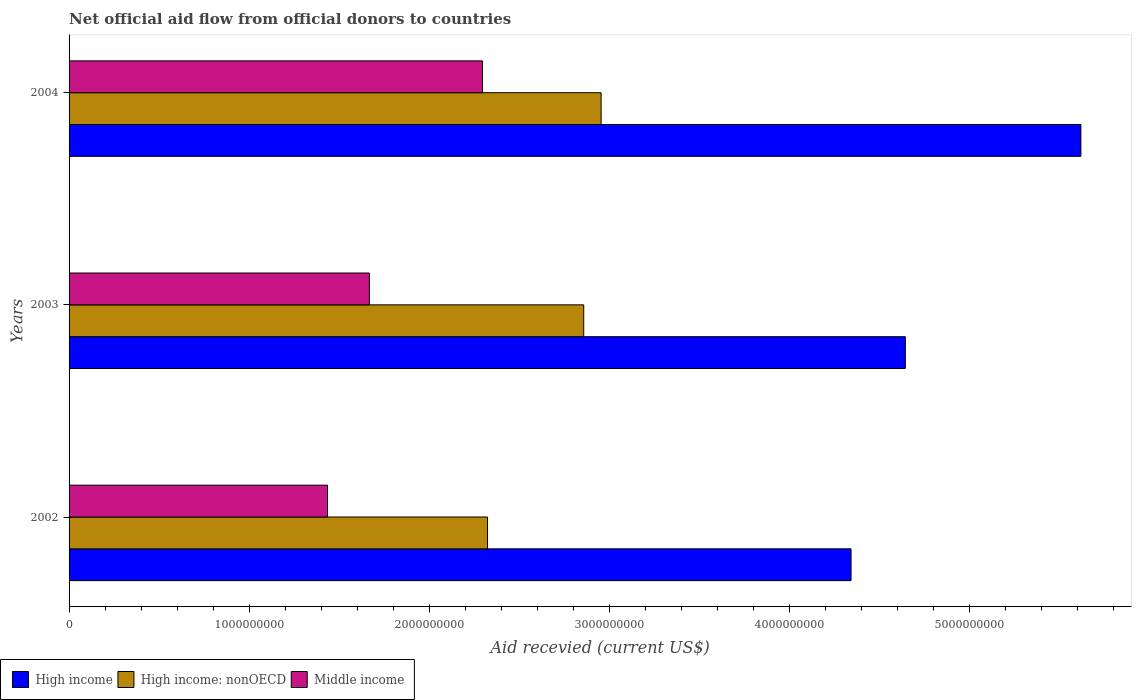How many groups of bars are there?
Offer a terse response. 3. Are the number of bars on each tick of the Y-axis equal?
Ensure brevity in your answer.  Yes. What is the label of the 1st group of bars from the top?
Your answer should be very brief. 2004. What is the total aid received in Middle income in 2002?
Make the answer very short. 1.43e+09. Across all years, what is the maximum total aid received in High income?
Offer a terse response. 5.62e+09. Across all years, what is the minimum total aid received in Middle income?
Your response must be concise. 1.43e+09. In which year was the total aid received in Middle income maximum?
Your response must be concise. 2004. What is the total total aid received in High income in the graph?
Your response must be concise. 1.46e+1. What is the difference between the total aid received in Middle income in 2002 and that in 2004?
Your answer should be very brief. -8.61e+08. What is the difference between the total aid received in High income: nonOECD in 2004 and the total aid received in High income in 2002?
Provide a succinct answer. -1.39e+09. What is the average total aid received in High income: nonOECD per year?
Keep it short and to the point. 2.71e+09. In the year 2004, what is the difference between the total aid received in High income and total aid received in High income: nonOECD?
Make the answer very short. 2.66e+09. In how many years, is the total aid received in Middle income greater than 800000000 US$?
Your answer should be compact. 3. What is the ratio of the total aid received in High income: nonOECD in 2003 to that in 2004?
Your answer should be very brief. 0.97. Is the total aid received in High income: nonOECD in 2002 less than that in 2003?
Your answer should be compact. Yes. Is the difference between the total aid received in High income in 2003 and 2004 greater than the difference between the total aid received in High income: nonOECD in 2003 and 2004?
Keep it short and to the point. No. What is the difference between the highest and the second highest total aid received in Middle income?
Provide a succinct answer. 6.28e+08. What is the difference between the highest and the lowest total aid received in High income?
Make the answer very short. 1.28e+09. In how many years, is the total aid received in Middle income greater than the average total aid received in Middle income taken over all years?
Provide a short and direct response. 1. What does the 2nd bar from the top in 2003 represents?
Provide a succinct answer. High income: nonOECD. What does the 1st bar from the bottom in 2004 represents?
Your answer should be compact. High income. Are the values on the major ticks of X-axis written in scientific E-notation?
Give a very brief answer. No. Where does the legend appear in the graph?
Your response must be concise. Bottom left. What is the title of the graph?
Provide a succinct answer. Net official aid flow from official donors to countries. Does "Sub-Saharan Africa (developing only)" appear as one of the legend labels in the graph?
Give a very brief answer. No. What is the label or title of the X-axis?
Make the answer very short. Aid recevied (current US$). What is the label or title of the Y-axis?
Provide a succinct answer. Years. What is the Aid recevied (current US$) of High income in 2002?
Keep it short and to the point. 4.34e+09. What is the Aid recevied (current US$) of High income: nonOECD in 2002?
Ensure brevity in your answer.  2.32e+09. What is the Aid recevied (current US$) in Middle income in 2002?
Your answer should be very brief. 1.43e+09. What is the Aid recevied (current US$) of High income in 2003?
Ensure brevity in your answer.  4.64e+09. What is the Aid recevied (current US$) of High income: nonOECD in 2003?
Make the answer very short. 2.86e+09. What is the Aid recevied (current US$) in Middle income in 2003?
Your answer should be very brief. 1.67e+09. What is the Aid recevied (current US$) of High income in 2004?
Offer a terse response. 5.62e+09. What is the Aid recevied (current US$) in High income: nonOECD in 2004?
Provide a succinct answer. 2.95e+09. What is the Aid recevied (current US$) of Middle income in 2004?
Give a very brief answer. 2.30e+09. Across all years, what is the maximum Aid recevied (current US$) in High income?
Your answer should be compact. 5.62e+09. Across all years, what is the maximum Aid recevied (current US$) of High income: nonOECD?
Your response must be concise. 2.95e+09. Across all years, what is the maximum Aid recevied (current US$) in Middle income?
Give a very brief answer. 2.30e+09. Across all years, what is the minimum Aid recevied (current US$) of High income?
Your answer should be compact. 4.34e+09. Across all years, what is the minimum Aid recevied (current US$) of High income: nonOECD?
Your answer should be compact. 2.32e+09. Across all years, what is the minimum Aid recevied (current US$) in Middle income?
Your answer should be compact. 1.43e+09. What is the total Aid recevied (current US$) of High income in the graph?
Offer a terse response. 1.46e+1. What is the total Aid recevied (current US$) of High income: nonOECD in the graph?
Make the answer very short. 8.13e+09. What is the total Aid recevied (current US$) of Middle income in the graph?
Your response must be concise. 5.40e+09. What is the difference between the Aid recevied (current US$) in High income in 2002 and that in 2003?
Your answer should be compact. -3.01e+08. What is the difference between the Aid recevied (current US$) of High income: nonOECD in 2002 and that in 2003?
Keep it short and to the point. -5.34e+08. What is the difference between the Aid recevied (current US$) of Middle income in 2002 and that in 2003?
Your answer should be very brief. -2.33e+08. What is the difference between the Aid recevied (current US$) in High income in 2002 and that in 2004?
Ensure brevity in your answer.  -1.28e+09. What is the difference between the Aid recevied (current US$) in High income: nonOECD in 2002 and that in 2004?
Give a very brief answer. -6.31e+08. What is the difference between the Aid recevied (current US$) of Middle income in 2002 and that in 2004?
Offer a terse response. -8.61e+08. What is the difference between the Aid recevied (current US$) in High income in 2003 and that in 2004?
Provide a succinct answer. -9.75e+08. What is the difference between the Aid recevied (current US$) of High income: nonOECD in 2003 and that in 2004?
Offer a terse response. -9.65e+07. What is the difference between the Aid recevied (current US$) in Middle income in 2003 and that in 2004?
Offer a very short reply. -6.28e+08. What is the difference between the Aid recevied (current US$) in High income in 2002 and the Aid recevied (current US$) in High income: nonOECD in 2003?
Provide a succinct answer. 1.48e+09. What is the difference between the Aid recevied (current US$) in High income in 2002 and the Aid recevied (current US$) in Middle income in 2003?
Offer a very short reply. 2.67e+09. What is the difference between the Aid recevied (current US$) in High income: nonOECD in 2002 and the Aid recevied (current US$) in Middle income in 2003?
Provide a succinct answer. 6.56e+08. What is the difference between the Aid recevied (current US$) of High income in 2002 and the Aid recevied (current US$) of High income: nonOECD in 2004?
Give a very brief answer. 1.39e+09. What is the difference between the Aid recevied (current US$) of High income in 2002 and the Aid recevied (current US$) of Middle income in 2004?
Your answer should be very brief. 2.05e+09. What is the difference between the Aid recevied (current US$) of High income: nonOECD in 2002 and the Aid recevied (current US$) of Middle income in 2004?
Offer a very short reply. 2.79e+07. What is the difference between the Aid recevied (current US$) of High income in 2003 and the Aid recevied (current US$) of High income: nonOECD in 2004?
Your answer should be very brief. 1.69e+09. What is the difference between the Aid recevied (current US$) in High income in 2003 and the Aid recevied (current US$) in Middle income in 2004?
Your answer should be very brief. 2.35e+09. What is the difference between the Aid recevied (current US$) in High income: nonOECD in 2003 and the Aid recevied (current US$) in Middle income in 2004?
Provide a short and direct response. 5.62e+08. What is the average Aid recevied (current US$) of High income per year?
Make the answer very short. 4.87e+09. What is the average Aid recevied (current US$) in High income: nonOECD per year?
Keep it short and to the point. 2.71e+09. What is the average Aid recevied (current US$) of Middle income per year?
Your answer should be very brief. 1.80e+09. In the year 2002, what is the difference between the Aid recevied (current US$) of High income and Aid recevied (current US$) of High income: nonOECD?
Your answer should be compact. 2.02e+09. In the year 2002, what is the difference between the Aid recevied (current US$) in High income and Aid recevied (current US$) in Middle income?
Keep it short and to the point. 2.91e+09. In the year 2002, what is the difference between the Aid recevied (current US$) of High income: nonOECD and Aid recevied (current US$) of Middle income?
Offer a very short reply. 8.89e+08. In the year 2003, what is the difference between the Aid recevied (current US$) in High income and Aid recevied (current US$) in High income: nonOECD?
Your answer should be compact. 1.79e+09. In the year 2003, what is the difference between the Aid recevied (current US$) of High income and Aid recevied (current US$) of Middle income?
Your answer should be compact. 2.98e+09. In the year 2003, what is the difference between the Aid recevied (current US$) of High income: nonOECD and Aid recevied (current US$) of Middle income?
Offer a terse response. 1.19e+09. In the year 2004, what is the difference between the Aid recevied (current US$) in High income and Aid recevied (current US$) in High income: nonOECD?
Provide a succinct answer. 2.66e+09. In the year 2004, what is the difference between the Aid recevied (current US$) of High income and Aid recevied (current US$) of Middle income?
Your response must be concise. 3.32e+09. In the year 2004, what is the difference between the Aid recevied (current US$) in High income: nonOECD and Aid recevied (current US$) in Middle income?
Make the answer very short. 6.58e+08. What is the ratio of the Aid recevied (current US$) of High income in 2002 to that in 2003?
Provide a short and direct response. 0.94. What is the ratio of the Aid recevied (current US$) of High income: nonOECD in 2002 to that in 2003?
Provide a succinct answer. 0.81. What is the ratio of the Aid recevied (current US$) of Middle income in 2002 to that in 2003?
Offer a terse response. 0.86. What is the ratio of the Aid recevied (current US$) of High income in 2002 to that in 2004?
Keep it short and to the point. 0.77. What is the ratio of the Aid recevied (current US$) in High income: nonOECD in 2002 to that in 2004?
Your answer should be very brief. 0.79. What is the ratio of the Aid recevied (current US$) of Middle income in 2002 to that in 2004?
Ensure brevity in your answer.  0.62. What is the ratio of the Aid recevied (current US$) in High income in 2003 to that in 2004?
Provide a short and direct response. 0.83. What is the ratio of the Aid recevied (current US$) in High income: nonOECD in 2003 to that in 2004?
Make the answer very short. 0.97. What is the ratio of the Aid recevied (current US$) in Middle income in 2003 to that in 2004?
Make the answer very short. 0.73. What is the difference between the highest and the second highest Aid recevied (current US$) of High income?
Offer a very short reply. 9.75e+08. What is the difference between the highest and the second highest Aid recevied (current US$) of High income: nonOECD?
Your answer should be compact. 9.65e+07. What is the difference between the highest and the second highest Aid recevied (current US$) of Middle income?
Offer a very short reply. 6.28e+08. What is the difference between the highest and the lowest Aid recevied (current US$) in High income?
Keep it short and to the point. 1.28e+09. What is the difference between the highest and the lowest Aid recevied (current US$) in High income: nonOECD?
Your answer should be very brief. 6.31e+08. What is the difference between the highest and the lowest Aid recevied (current US$) of Middle income?
Make the answer very short. 8.61e+08. 